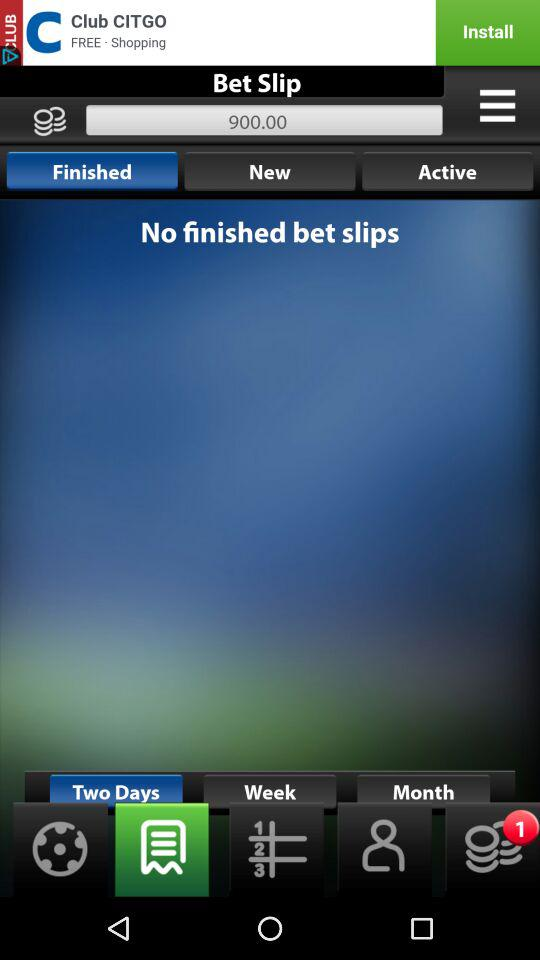When was the last bet made?
When the provided information is insufficient, respond with <no answer>. <no answer> 